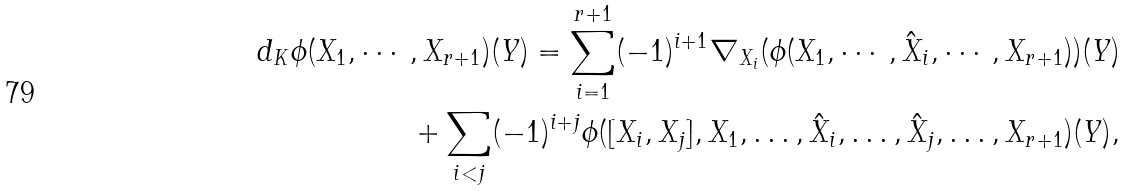Convert formula to latex. <formula><loc_0><loc_0><loc_500><loc_500>d _ { K } \phi ( X _ { 1 } , \cdots , X _ { r + 1 } ) ( Y ) = \sum _ { i = 1 } ^ { r + 1 } ( - 1 ) ^ { i + 1 } \nabla _ { X _ { i } } ( \phi ( X _ { 1 } , \cdots , \hat { X } _ { i } , \cdots , X _ { r + 1 } ) ) ( Y ) \\ + \sum _ { i < j } ( - 1 ) ^ { i + j } \phi ( [ X _ { i } , X _ { j } ] , X _ { 1 } , \dots , \hat { X } _ { i } , \dots , \hat { X } _ { j } , \dots , X _ { r + 1 } ) ( Y ) ,</formula> 